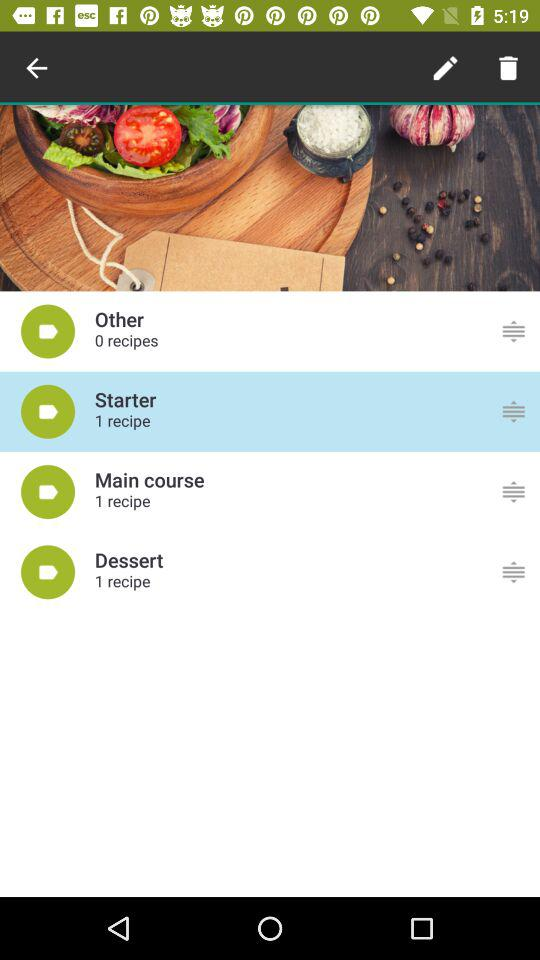How many recipes are there in total?
Answer the question using a single word or phrase. 3 